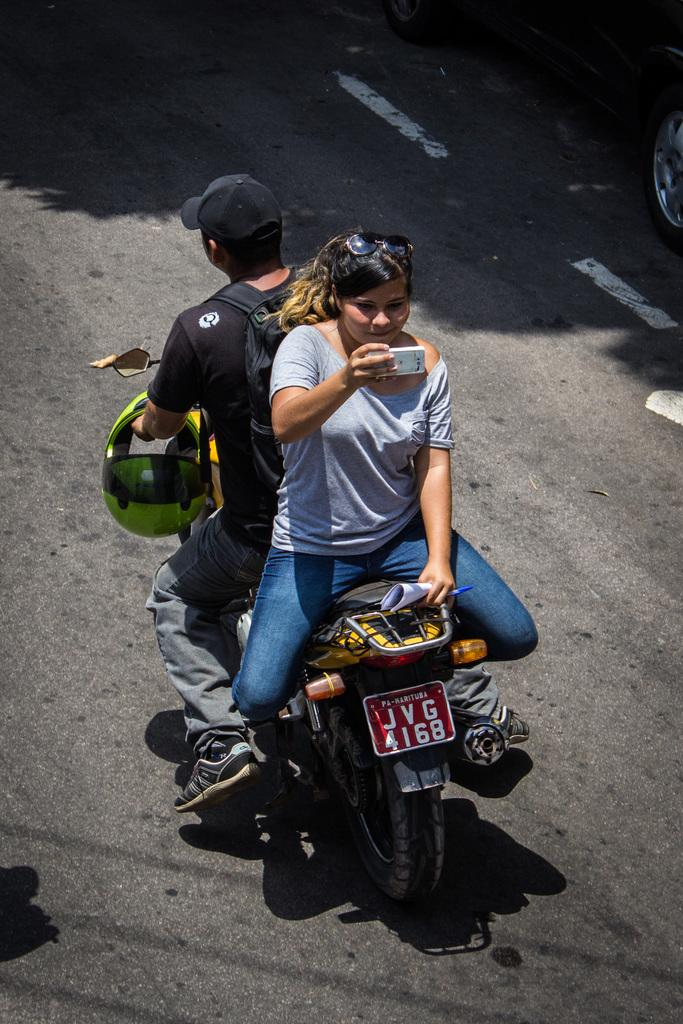How many people are in the image? There are two persons in the image. What are the two persons doing in the image? The two persons are sitting on a motorbike. What items are being held by the persons in the image? One person is holding a helmet, one person is holding a wire bag, one person is holding a mobile, and one person is holding papers. Can you see any giants in the image? No, there are no giants present in the image. Are the persons in the image flying? No, the persons in the image are not flying. 